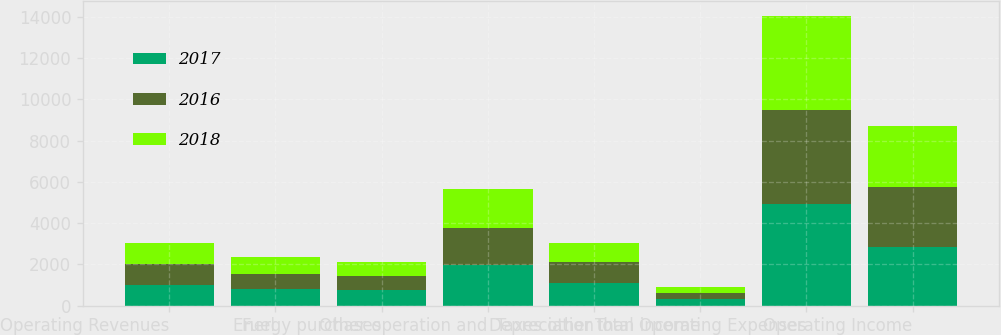<chart> <loc_0><loc_0><loc_500><loc_500><stacked_bar_chart><ecel><fcel>Operating Revenues<fcel>Fuel<fcel>Energy purchases<fcel>Other operation and<fcel>Depreciation<fcel>Taxes other than income<fcel>Total Operating Expenses<fcel>Operating Income<nl><fcel>2017<fcel>1008<fcel>799<fcel>745<fcel>1983<fcel>1094<fcel>312<fcel>4933<fcel>2852<nl><fcel>2016<fcel>1008<fcel>759<fcel>685<fcel>1802<fcel>1008<fcel>292<fcel>4546<fcel>2901<nl><fcel>2018<fcel>1008<fcel>791<fcel>706<fcel>1857<fcel>926<fcel>301<fcel>4581<fcel>2936<nl></chart> 